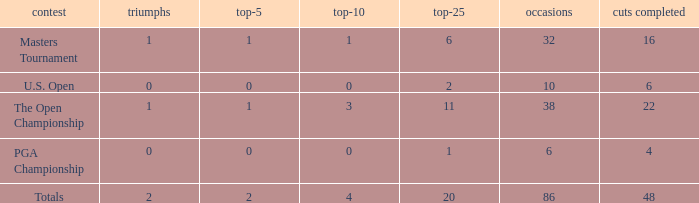Tell me the total number of events for tournament of masters tournament and top 25 less than 6 0.0. Parse the table in full. {'header': ['contest', 'triumphs', 'top-5', 'top-10', 'top-25', 'occasions', 'cuts completed'], 'rows': [['Masters Tournament', '1', '1', '1', '6', '32', '16'], ['U.S. Open', '0', '0', '0', '2', '10', '6'], ['The Open Championship', '1', '1', '3', '11', '38', '22'], ['PGA Championship', '0', '0', '0', '1', '6', '4'], ['Totals', '2', '2', '4', '20', '86', '48']]} 